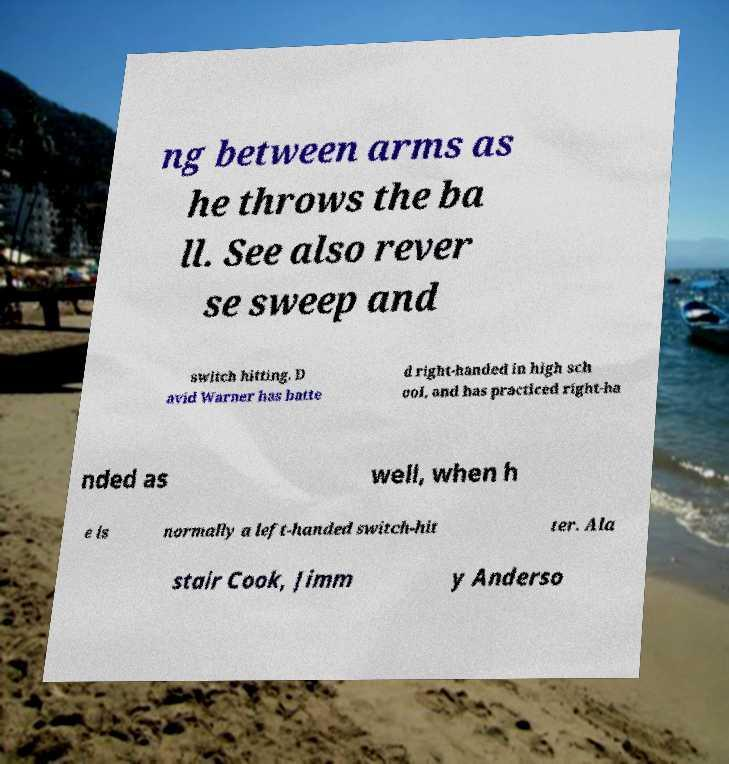What messages or text are displayed in this image? I need them in a readable, typed format. ng between arms as he throws the ba ll. See also rever se sweep and switch hitting. D avid Warner has batte d right-handed in high sch ool, and has practiced right-ha nded as well, when h e is normally a left-handed switch-hit ter. Ala stair Cook, Jimm y Anderso 